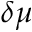Convert formula to latex. <formula><loc_0><loc_0><loc_500><loc_500>\delta \mu</formula> 